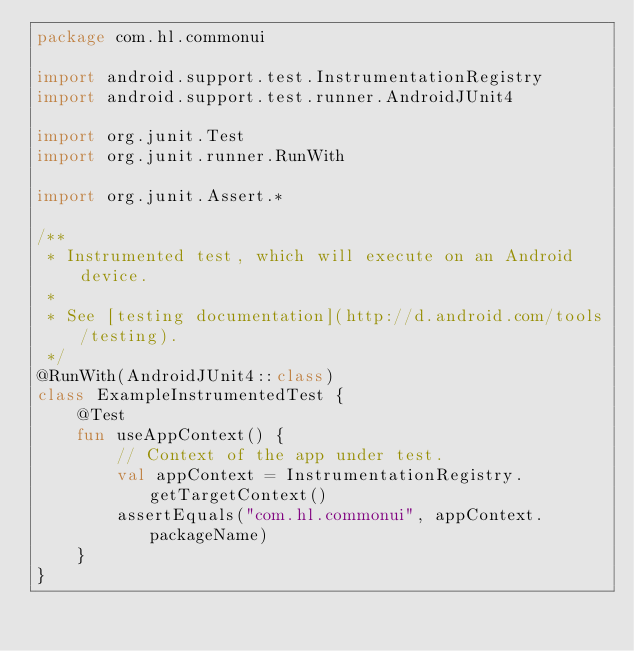Convert code to text. <code><loc_0><loc_0><loc_500><loc_500><_Kotlin_>package com.hl.commonui

import android.support.test.InstrumentationRegistry
import android.support.test.runner.AndroidJUnit4

import org.junit.Test
import org.junit.runner.RunWith

import org.junit.Assert.*

/**
 * Instrumented test, which will execute on an Android device.
 *
 * See [testing documentation](http://d.android.com/tools/testing).
 */
@RunWith(AndroidJUnit4::class)
class ExampleInstrumentedTest {
    @Test
    fun useAppContext() {
        // Context of the app under test.
        val appContext = InstrumentationRegistry.getTargetContext()
        assertEquals("com.hl.commonui", appContext.packageName)
    }
}
</code> 